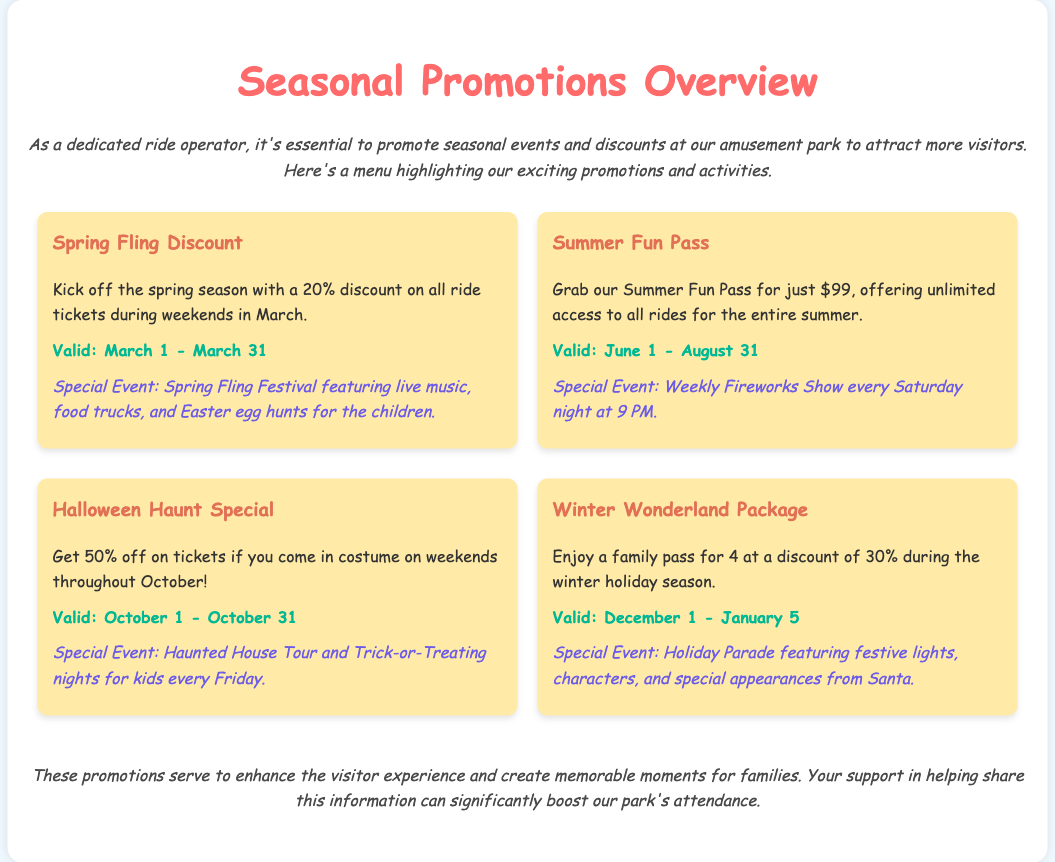What is the discount for the Spring Fling promotion? The document states a 20% discount on all ride tickets during weekends in March for the Spring Fling promotion.
Answer: 20% When does the Summer Fun Pass start? The Summer Fun Pass is valid from June 1 according to the promotions section in the document.
Answer: June 1 What event occurs every Saturday night during the summer? The document mentions a Weekly Fireworks Show happening every Saturday night at 9 PM during the summer.
Answer: Weekly Fireworks Show What is the discount percentage for the Winter Wonderland Package? The document indicates that the Winter Wonderland Package offers a discount of 30% during the holiday season.
Answer: 30% On which date does the Halloween Haunt Special end? According to the document, the Halloween Haunt Special is valid until October 31.
Answer: October 31 What special event is associated with the Winter Wonderland Package? The document highlights a Holiday Parade featuring festive lights, characters, and special appearances from Santa under the Winter Wonderland Package.
Answer: Holiday Parade How much is the Summer Fun Pass? The document states that the Summer Fun Pass is available for $99.
Answer: $99 What is the event for children during the Spring Fling Festival? The document specifies that the Spring Fling Festival includes Easter egg hunts for the children.
Answer: Easter egg hunts What discount do visitors receive for coming in costume during October? According to the document, visitors get 50% off on tickets if they come in costume on weekends in October.
Answer: 50% off 